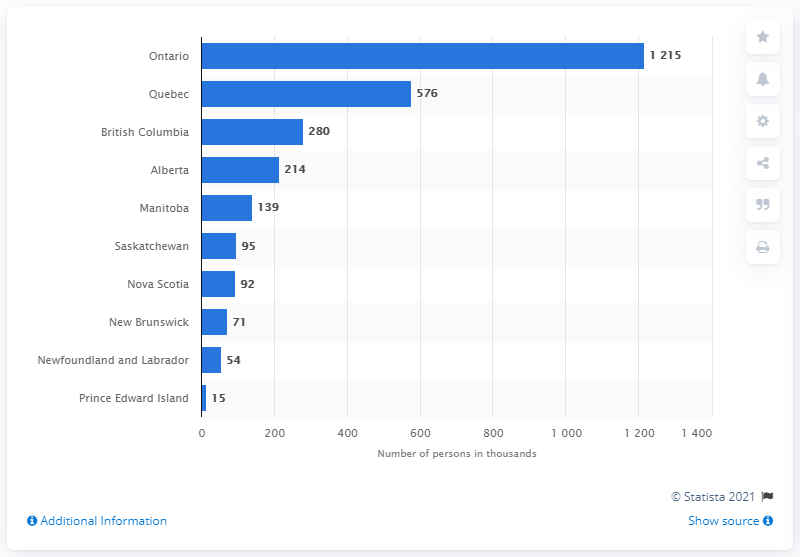Draw attention to some important aspects in this diagram. In 2019, Ontario had the largest number of people living in low income households, according to the latest census data. 